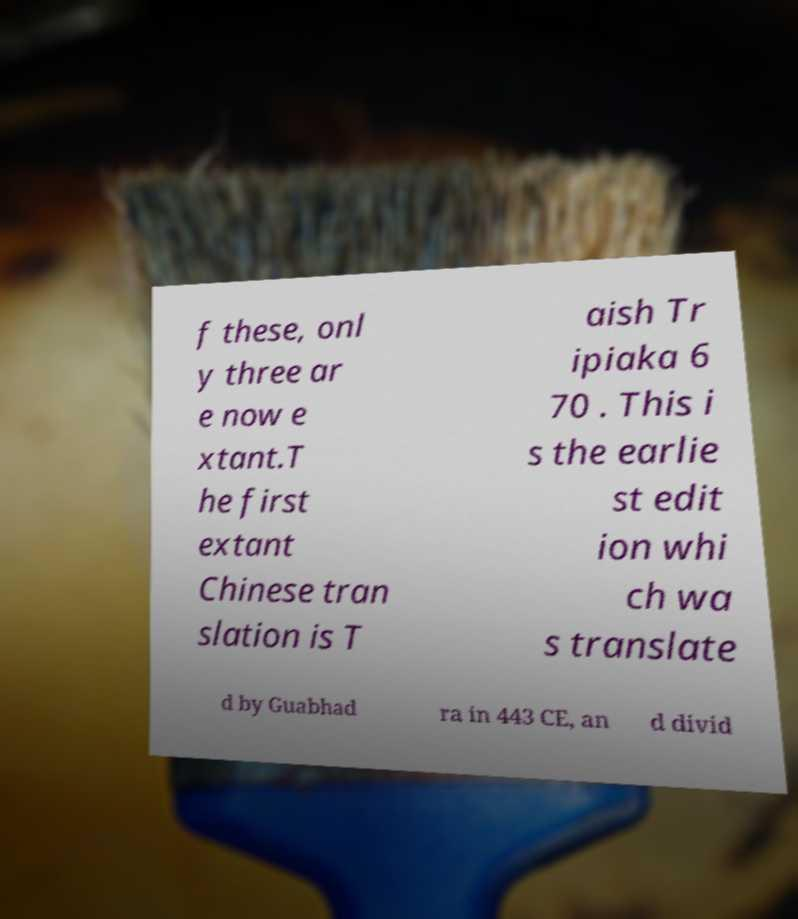What messages or text are displayed in this image? I need them in a readable, typed format. f these, onl y three ar e now e xtant.T he first extant Chinese tran slation is T aish Tr ipiaka 6 70 . This i s the earlie st edit ion whi ch wa s translate d by Guabhad ra in 443 CE, an d divid 